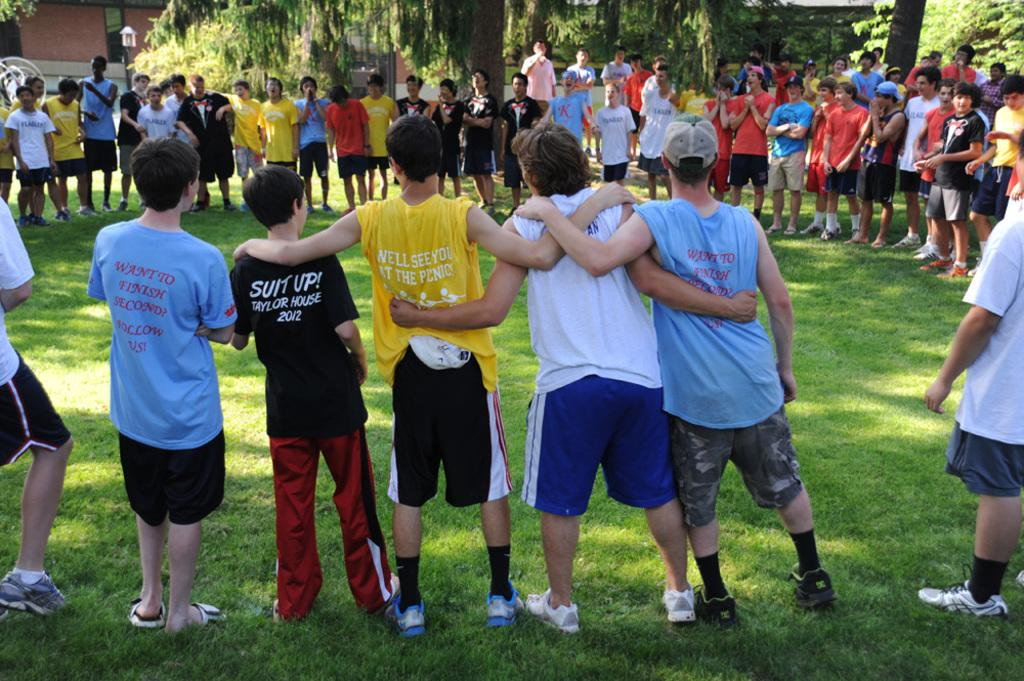Provide a one-sentence caption for the provided image. Several kids stand around in a circle. One is wearing a black shirt that reads "suit up!". 